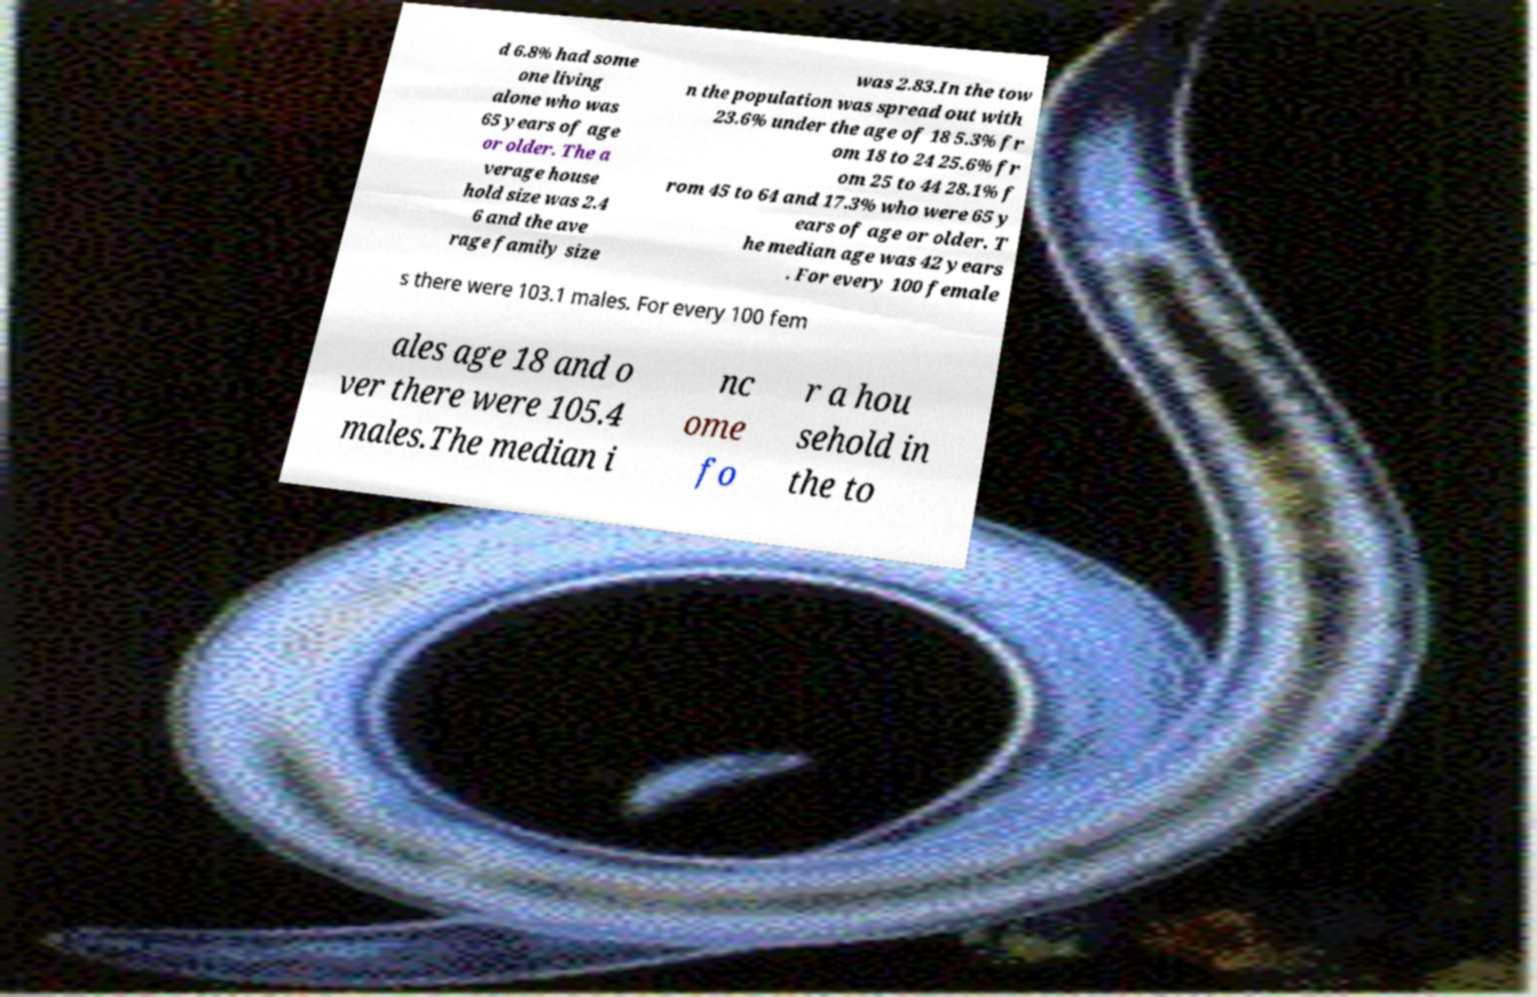Could you extract and type out the text from this image? d 6.8% had some one living alone who was 65 years of age or older. The a verage house hold size was 2.4 6 and the ave rage family size was 2.83.In the tow n the population was spread out with 23.6% under the age of 18 5.3% fr om 18 to 24 25.6% fr om 25 to 44 28.1% f rom 45 to 64 and 17.3% who were 65 y ears of age or older. T he median age was 42 years . For every 100 female s there were 103.1 males. For every 100 fem ales age 18 and o ver there were 105.4 males.The median i nc ome fo r a hou sehold in the to 